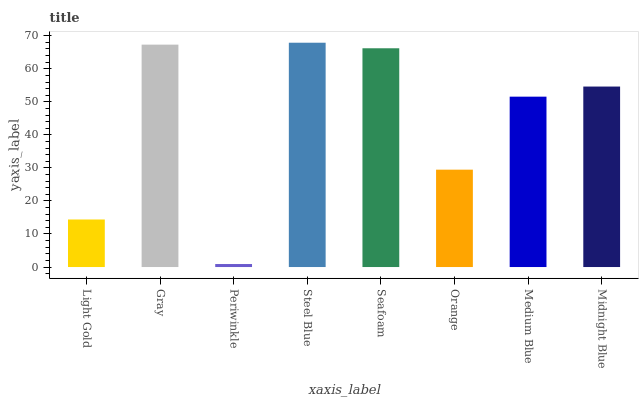Is Periwinkle the minimum?
Answer yes or no. Yes. Is Steel Blue the maximum?
Answer yes or no. Yes. Is Gray the minimum?
Answer yes or no. No. Is Gray the maximum?
Answer yes or no. No. Is Gray greater than Light Gold?
Answer yes or no. Yes. Is Light Gold less than Gray?
Answer yes or no. Yes. Is Light Gold greater than Gray?
Answer yes or no. No. Is Gray less than Light Gold?
Answer yes or no. No. Is Midnight Blue the high median?
Answer yes or no. Yes. Is Medium Blue the low median?
Answer yes or no. Yes. Is Seafoam the high median?
Answer yes or no. No. Is Seafoam the low median?
Answer yes or no. No. 